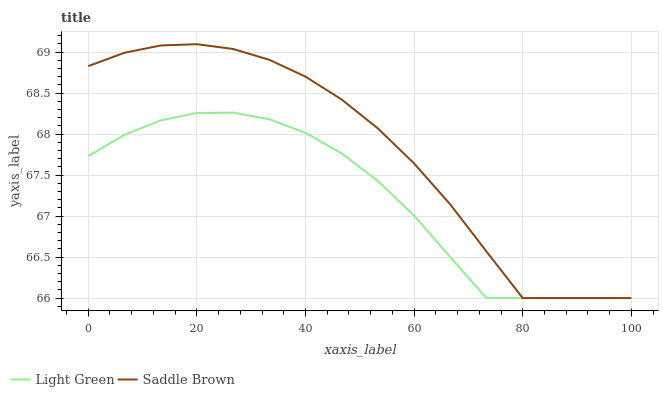Does Light Green have the minimum area under the curve?
Answer yes or no. Yes. Does Saddle Brown have the maximum area under the curve?
Answer yes or no. Yes. Does Light Green have the maximum area under the curve?
Answer yes or no. No. Is Light Green the smoothest?
Answer yes or no. Yes. Is Saddle Brown the roughest?
Answer yes or no. Yes. Is Light Green the roughest?
Answer yes or no. No. Does Saddle Brown have the lowest value?
Answer yes or no. Yes. Does Saddle Brown have the highest value?
Answer yes or no. Yes. Does Light Green have the highest value?
Answer yes or no. No. Does Saddle Brown intersect Light Green?
Answer yes or no. Yes. Is Saddle Brown less than Light Green?
Answer yes or no. No. Is Saddle Brown greater than Light Green?
Answer yes or no. No. 